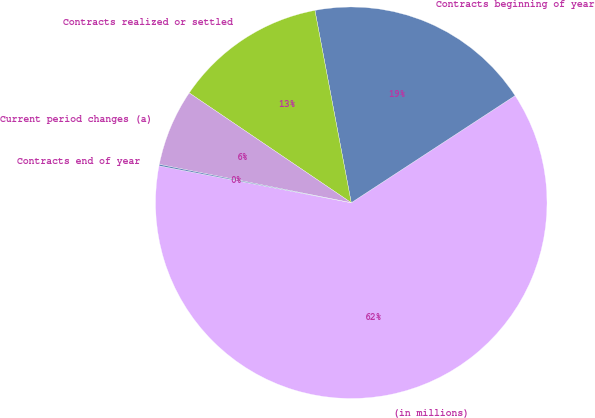Convert chart. <chart><loc_0><loc_0><loc_500><loc_500><pie_chart><fcel>(in millions)<fcel>Contracts beginning of year<fcel>Contracts realized or settled<fcel>Current period changes (a)<fcel>Contracts end of year<nl><fcel>62.24%<fcel>18.76%<fcel>12.55%<fcel>6.34%<fcel>0.12%<nl></chart> 